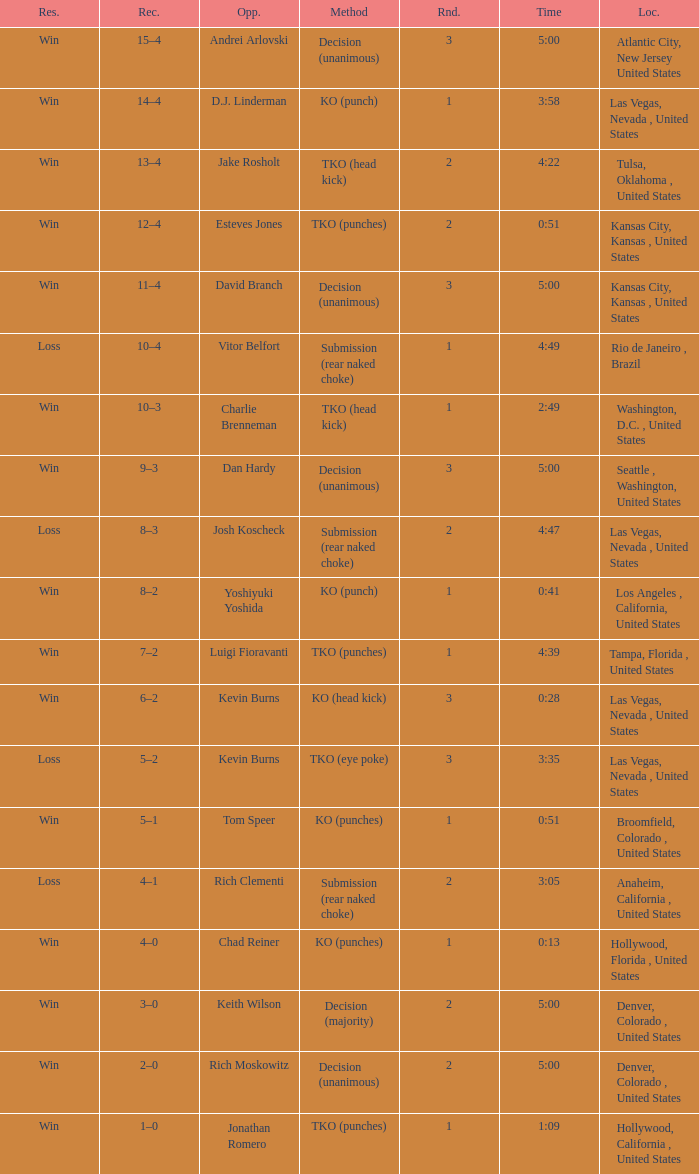What is the upshot for encounters less than 2 against d.j. linderman? Win. 